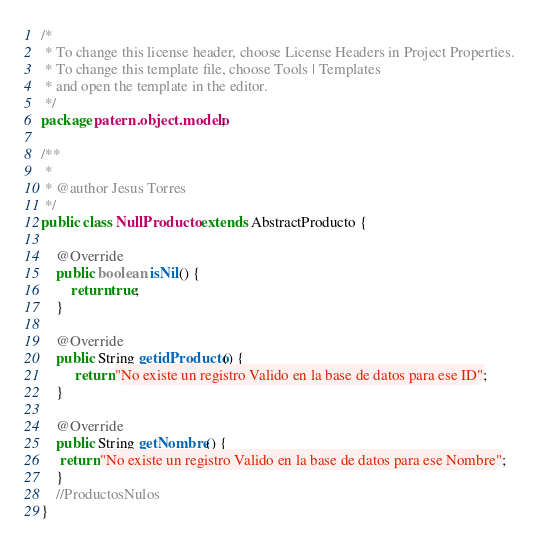<code> <loc_0><loc_0><loc_500><loc_500><_Java_>/*
 * To change this license header, choose License Headers in Project Properties.
 * To change this template file, choose Tools | Templates
 * and open the template in the editor.
 */
package patern.object.modelo;

/**
 *
 * @author Jesus Torres
 */
public class NullProducto extends AbstractProducto {

    @Override
    public boolean isNil() {
        return true;
    }

    @Override
    public String getidProducto() {
         return "No existe un registro Valido en la base de datos para ese ID";
    }

    @Override
    public String getNombre() {
     return "No existe un registro Valido en la base de datos para ese Nombre";
    }
    //ProductosNulos
}
</code> 